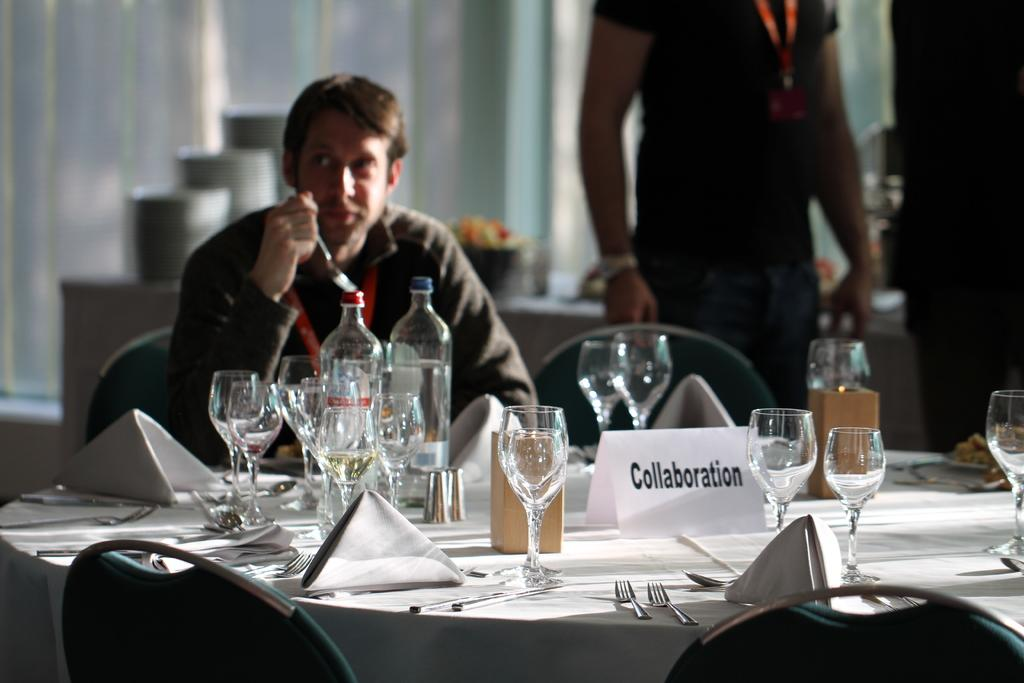What is the man in the image doing? The man is sitting on a chair in the image. How many chairs are visible in the image? There are additional chairs in the image. What objects are present in the image that might be used for drinking? There are glasses present in the image. What type of sail can be seen on the car in the image? There is no car or sail present in the image; it features a man sitting on a chair and additional chairs. 